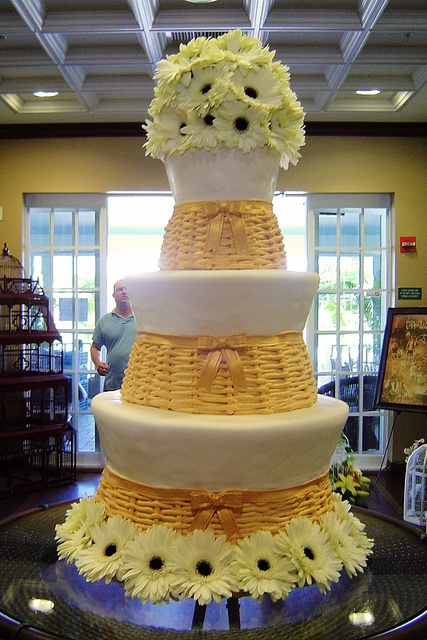Describe the objects in this image and their specific colors. I can see cake in black, tan, olive, gray, and darkgray tones, dining table in black, darkgreen, and gray tones, people in black, darkgray, gray, and lightgray tones, and car in black, navy, darkgray, and gray tones in this image. 